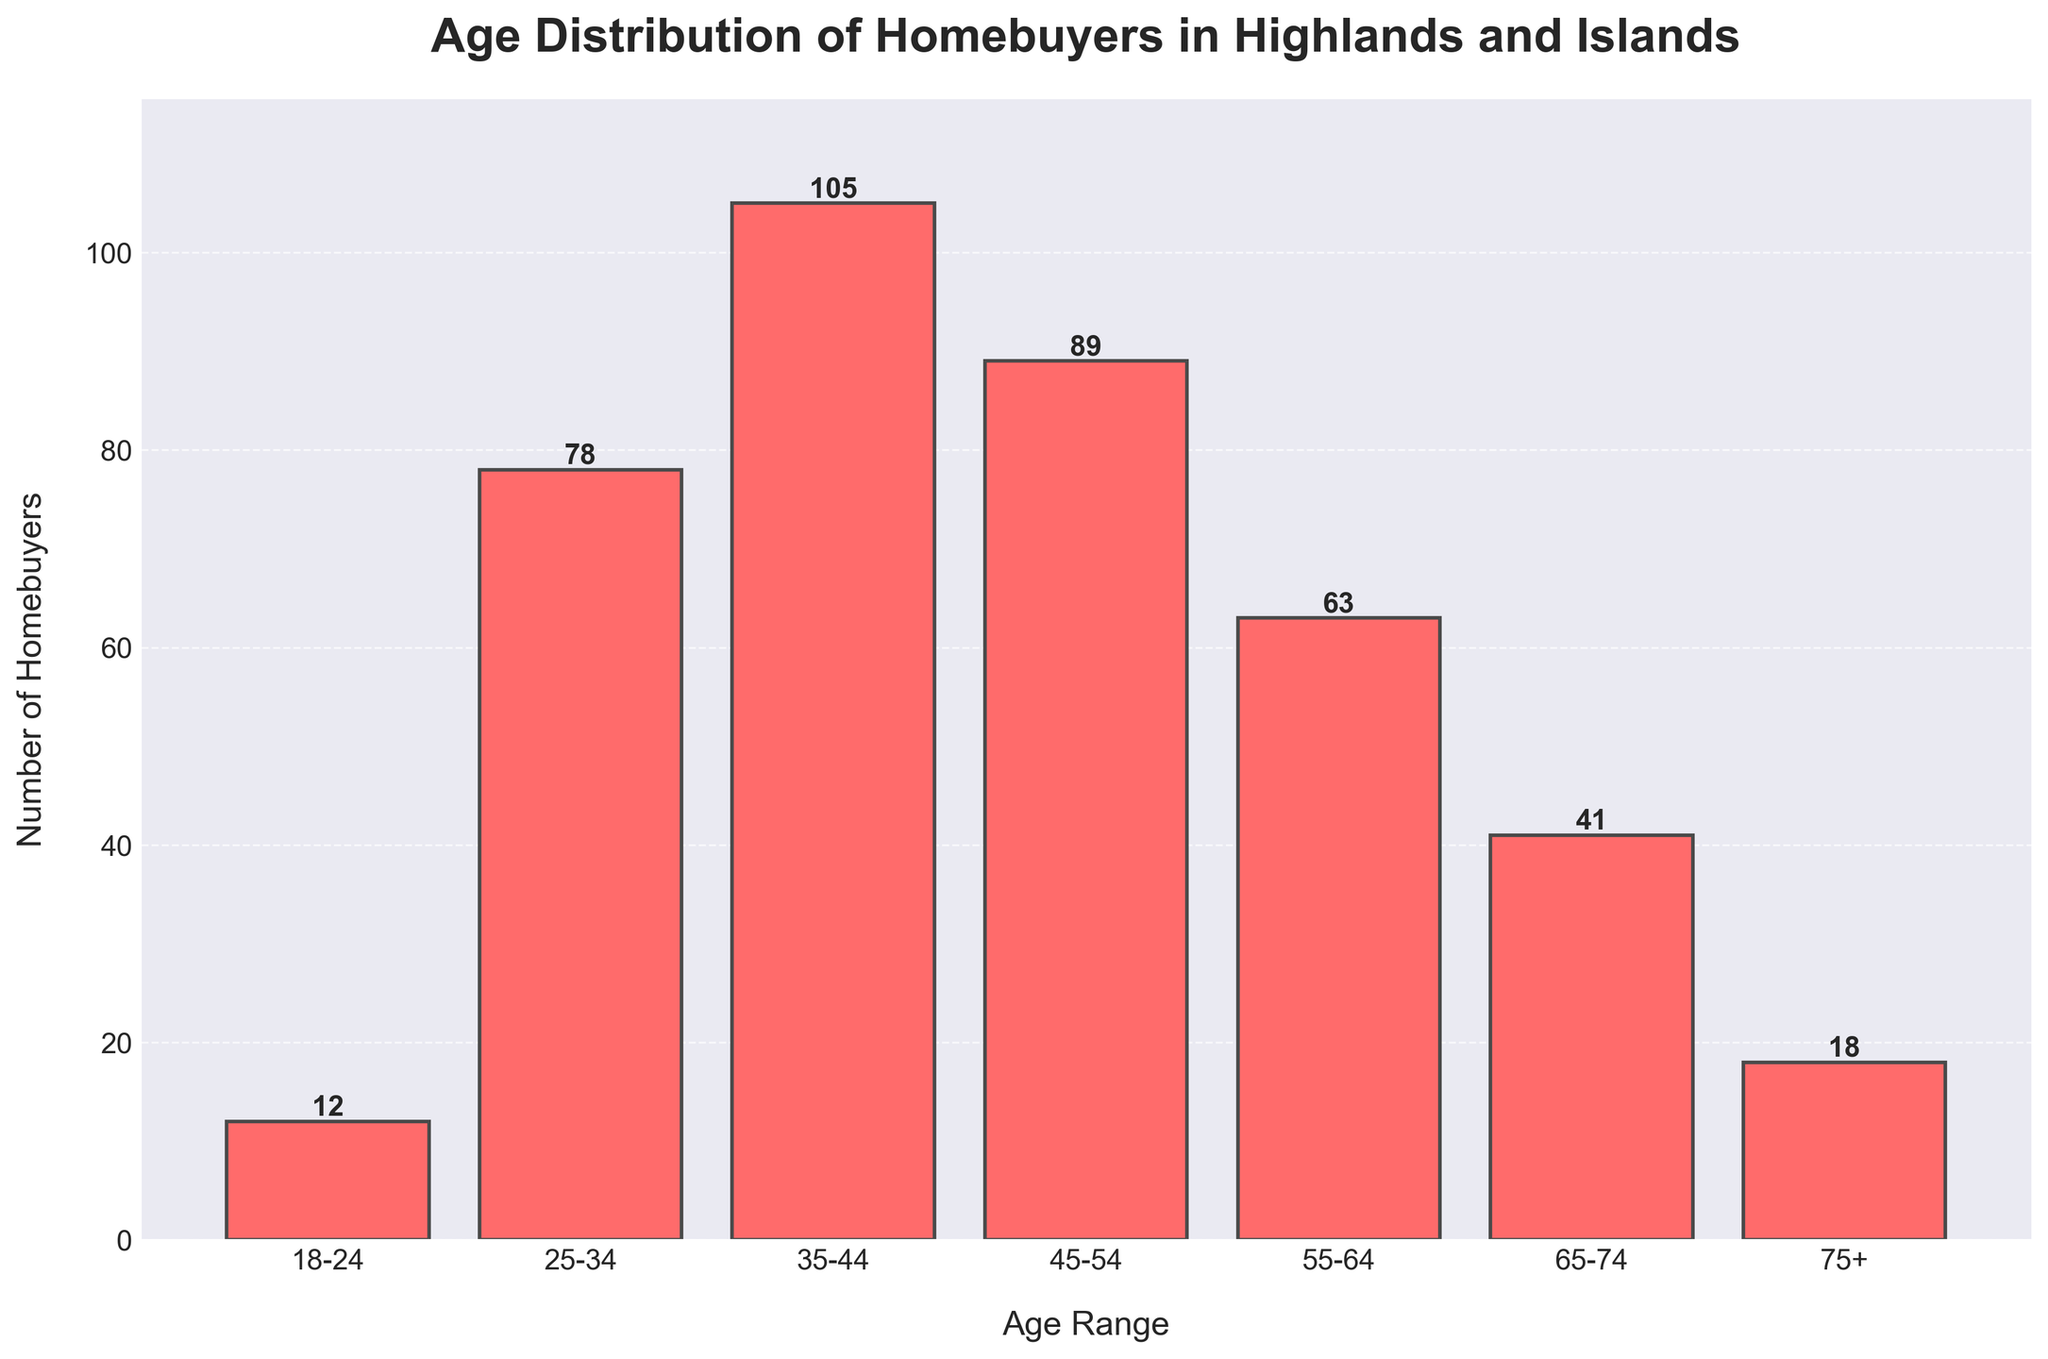what is the age range with the highest number of homebuyers? Identify the age range with the tallest bar in the histogram, which represents the age range with the highest number of homebuyers.
Answer: 35-44 How many homebuyers are in the 55-64 age range? Look at the bar corresponding to the 55-64 age range and read the number displayed above it.
Answer: 63 what is the total number of homebuyers between the ages of 18 and 44? Sum the number of homebuyers in the 18-24, 25-34, and 35-44 age ranges: 12 + 78 + 105.
Answer: 195 Which age range has the fewest homebuyers? Identify the age range with the shortest bar in the histogram, which represents the age range with the fewest homebuyers.
Answer: 18-24 How many more homebuyers are there in the 35-44 age range compared to the 75+ age range? Subtract the number of homebuyers in the 75+ age range from the number of homebuyers in the 35-44 age range: 105 - 18.
Answer: 87 What is the combined number of homebuyers for the age ranges 45-54 and 55-64? Add the number of homebuyers in the two age ranges: 89 + 63.
Answer: 152 Which age range has a number of homebuyers closest to 50? Compare the number of homebuyers in each age range to 50 and see which is closest.
Answer: 65-74 What is the average number of homebuyers in the age ranges from 25-34 to 55-64? Sum the number of homebuyers in the 25-34, 35-44, 45-54, and 55-64 age ranges and divide by 4: (78 + 105 + 89 + 63) / 4.
Answer: 83.75 Are there more homebuyers in the 25-34 age range or the 65-74 age range? Compare the number of homebuyers in the 25-34 age range to the number in the 65-74 age range: 78 vs. 41.
Answer: 25-34 What is the percentage of homebuyers in the 45-54 age range relative to the total number of homebuyers? Find the total number of homebuyers (406), then divide the number of homebuyers in the 45-54 age range (89) by the total and multiply by 100: (89 / 406) * 100.
Answer: ~21.9% 